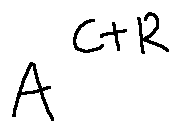Convert formula to latex. <formula><loc_0><loc_0><loc_500><loc_500>A ^ { C + R }</formula> 